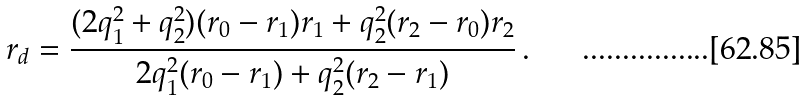Convert formula to latex. <formula><loc_0><loc_0><loc_500><loc_500>r _ { d } = \frac { ( 2 q _ { 1 } ^ { 2 } + q _ { 2 } ^ { 2 } ) ( r _ { 0 } - r _ { 1 } ) r _ { 1 } + q _ { 2 } ^ { 2 } ( r _ { 2 } - r _ { 0 } ) r _ { 2 } } { 2 q _ { 1 } ^ { 2 } ( r _ { 0 } - r _ { 1 } ) + q _ { 2 } ^ { 2 } ( r _ { 2 } - r _ { 1 } ) } \, .</formula> 